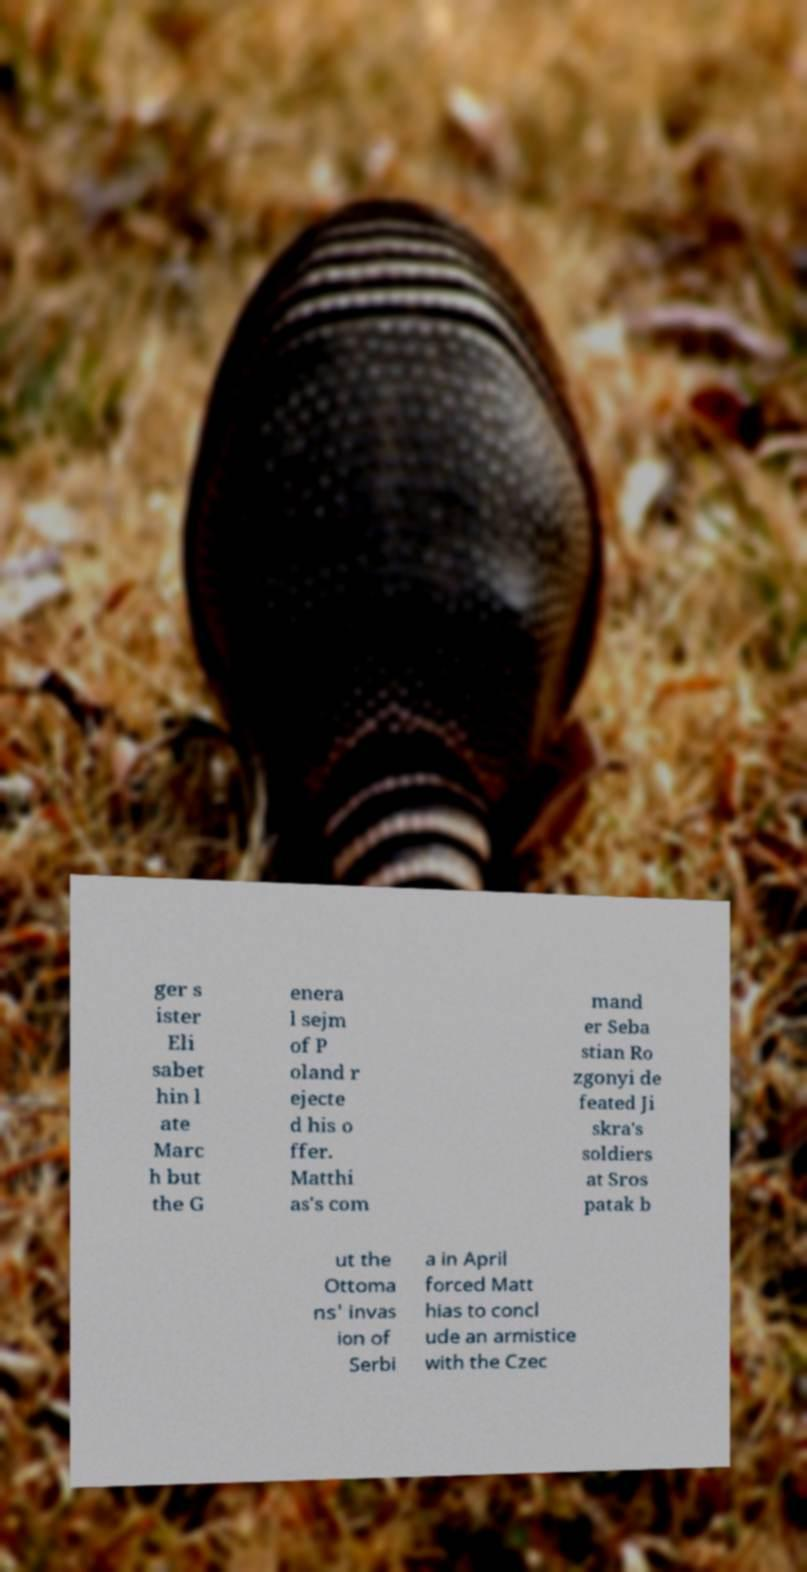For documentation purposes, I need the text within this image transcribed. Could you provide that? ger s ister Eli sabet hin l ate Marc h but the G enera l sejm of P oland r ejecte d his o ffer. Matthi as's com mand er Seba stian Ro zgonyi de feated Ji skra's soldiers at Sros patak b ut the Ottoma ns' invas ion of Serbi a in April forced Matt hias to concl ude an armistice with the Czec 